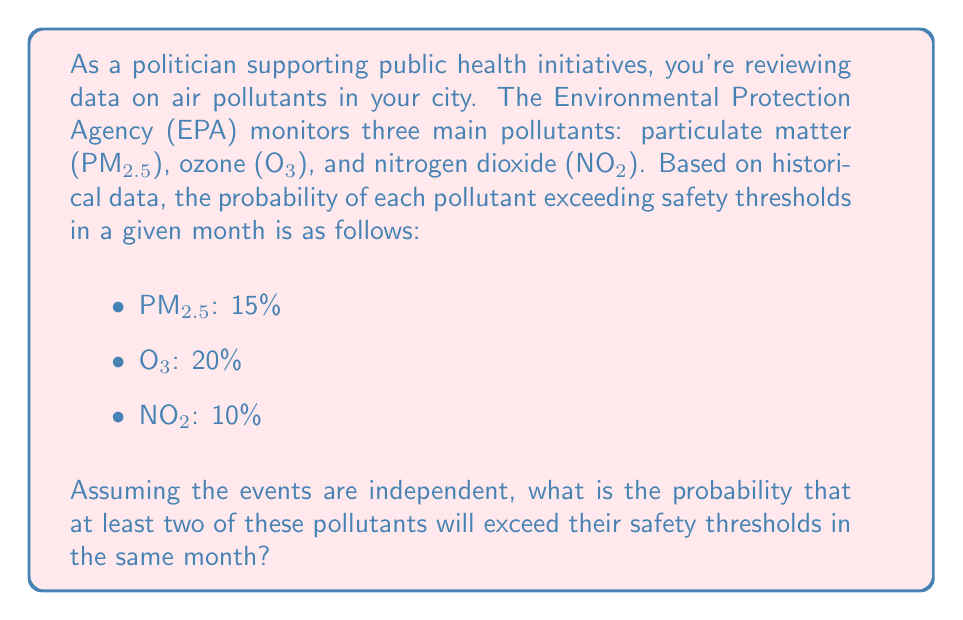Provide a solution to this math problem. To solve this problem, we'll use the concept of complementary events and the addition rule of probability.

Let's define the event A as "at least two pollutants exceed their safety thresholds."

The complement of A would be "zero or one pollutant exceeds its safety threshold."

We can calculate the probability of A by subtracting the probability of its complement from 1:

$$P(A) = 1 - P(\text{zero or one pollutant exceeds})$$

Now, let's calculate the probability of zero or one pollutant exceeding:

1. Probability of no pollutants exceeding:
   $$P(\text{none}) = (1-0.15)(1-0.20)(1-0.10) = 0.85 \times 0.80 \times 0.90 = 0.612$$

2. Probability of only PM2.5 exceeding:
   $$P(\text{only PM2.5}) = 0.15 \times 0.80 \times 0.90 = 0.108$$

3. Probability of only O₃ exceeding:
   $$P(\text{only O₃}) = 0.85 \times 0.20 \times 0.90 = 0.153$$

4. Probability of only NO₂ exceeding:
   $$P(\text{only NO₂}) = 0.85 \times 0.80 \times 0.10 = 0.068$$

Sum these probabilities:
$$P(\text{zero or one}) = 0.612 + 0.108 + 0.153 + 0.068 = 0.941$$

Therefore, the probability of at least two pollutants exceeding their safety thresholds is:

$$P(A) = 1 - 0.941 = 0.059$$
Answer: The probability that at least two of these pollutants will exceed their safety thresholds in the same month is 0.059 or 5.9%. 